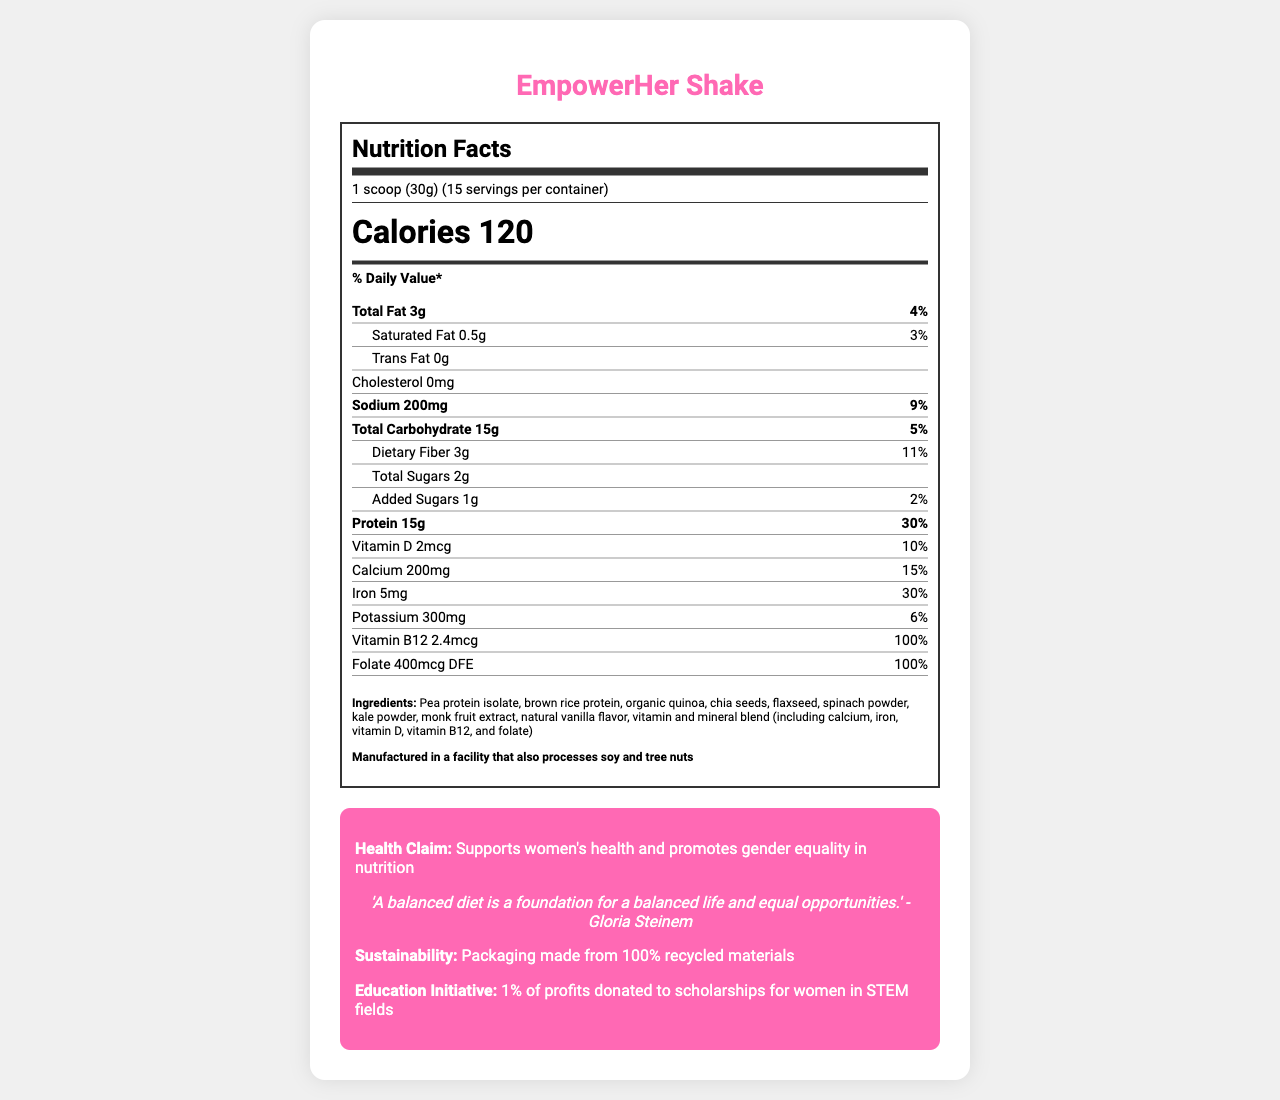what is the serving size for EmpowerHer Shake? The document specifies that the serving size for the EmpowerHer Shake is 1 scoop, which is 30 grams.
Answer: 1 scoop (30g) how many servings are there per container? The document states that there are 15 servings per container.
Answer: 15 how many calories are in one serving of the EmpowerHer Shake? The document lists that one serving of the EmpoweHer Shake contains 120 calories.
Answer: 120 what is the total fat content per serving? The document specifies that one serving contains 3 grams of total fat.
Answer: 3g what is the daily value percentage for protein? The document shows that the daily value percentage for protein is 30%.
Answer: 30% what vitamins are included in the EmpowerHer Shake? A. Vitamin A and C B. Vitamin D and B12 C. Vitamin E and K The document includes Vitamin D (2mcg) and Vitamin B12 (2.4mcg) as part of the nutrition facts.
Answer: B which mineral has the highest daily value percentage in the shake? A. Calcium B. Iron C. Potassium The document lists Iron with a Daily Value percentage of 30%, which is higher than Calcium (15%) and Potassium (6%).
Answer: B is the EmpowerHer Shake free from trans fat? The document states that the trans fat content is 0g, indicating it is free from trans fat.
Answer: Yes summarize the main information given in the document. The document provides an overview of the nutritional content and other relevant information about the EmpowerHer Shake, highlighting its benefits, ingredients, sustainability, and its contribution to educational initiatives for women in STEM fields.
Answer: The EmpowerHer Shake is a plant-based meal replacement shake aimed at busy female professionals and students. It offers detailed nutrition facts including calories, fats, proteins, vitamins, and minerals. It promotes women’s health and supports gender equality in nutrition, includes ingredients aiming for a balanced diet, and mentions sustainability efforts and an education initiative. how much dietary fiber is in each serving? The document specifies that each serving contains 3 grams of dietary fiber.
Answer: 3g what is the allergen information for the shake? The document states that the EmpowerHer Shake is manufactured in a facility that processes soy and tree nuts.
Answer: Manufactured in a facility that also processes soy and tree nuts what is the amount of added sugars per serving and its daily value percentage? The document shows that one serving has 1 gram of added sugars, which is 2% of the daily value.
Answer: 1g, 2% how many grams of total carbohydrates are there per serving? According to the document, each serving of the EmpowerHer Shake contains 15 grams of total carbohydrates.
Answer: 15g what is the sustainability claim made on the document? The document states that the packaging of the EmpowerHer Shake is made from 100% recycled materials.
Answer: Packaging made from 100% recycled materials how much calcium does one serving provide? The document lists that one serving provides 200mg of calcium.
Answer: 200mg what is the educational initiative linked to the EmpowerHer Shake? A. Scholarships for women in STEM fields B. Research on nutritional health C. Women’s health awareness programs The document states that 1% of profits are donated to scholarships for women in STEM fields as part of the educational initiative.
Answer: A what is the gender equality quote in the document? The document includes a quote by Gloria Steinem emphasizing the importance of a balanced diet for a balanced life and equal opportunities.
Answer: 'A balanced diet is a foundation for a balanced life and equal opportunities.' - Gloria Steinem can I determine the flavor of the EmpowerHer Shake from the document? The document mentions "natural vanilla flavor" as one of the ingredients, indicating the shake is vanilla flavored.
Answer: Yes what are the main protein sources in the EmpowerHer Shake? The document lists pea protein isolate, brown rice protein, and organic quinoa as the main protein sources.
Answer: Pea protein isolate, brown rice protein, organic quinoa 